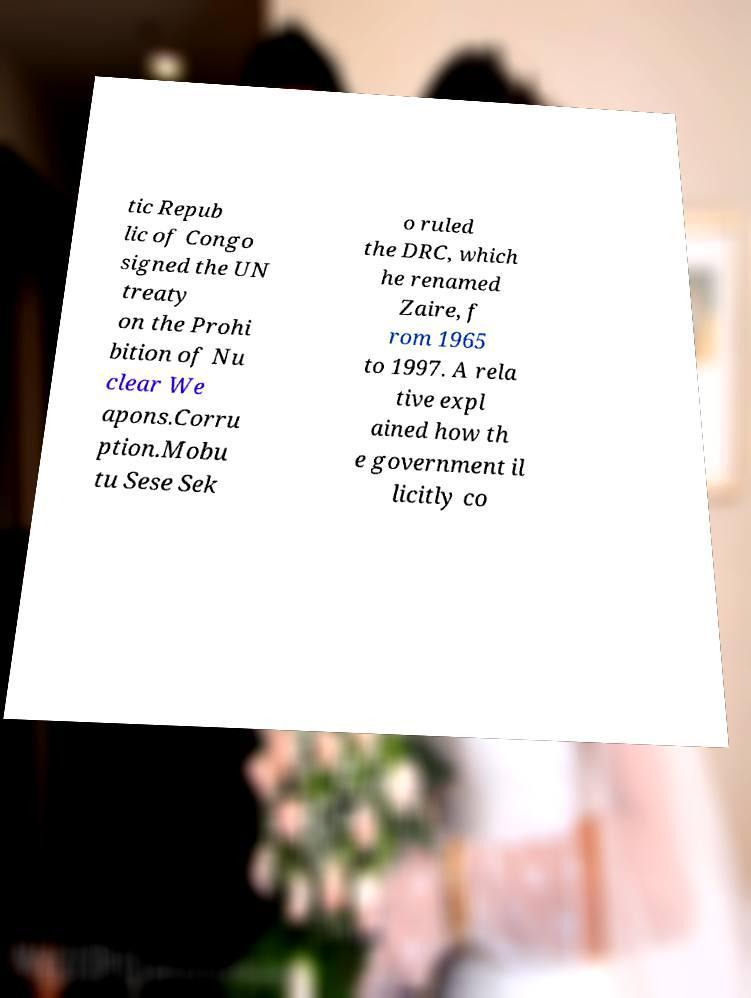For documentation purposes, I need the text within this image transcribed. Could you provide that? tic Repub lic of Congo signed the UN treaty on the Prohi bition of Nu clear We apons.Corru ption.Mobu tu Sese Sek o ruled the DRC, which he renamed Zaire, f rom 1965 to 1997. A rela tive expl ained how th e government il licitly co 